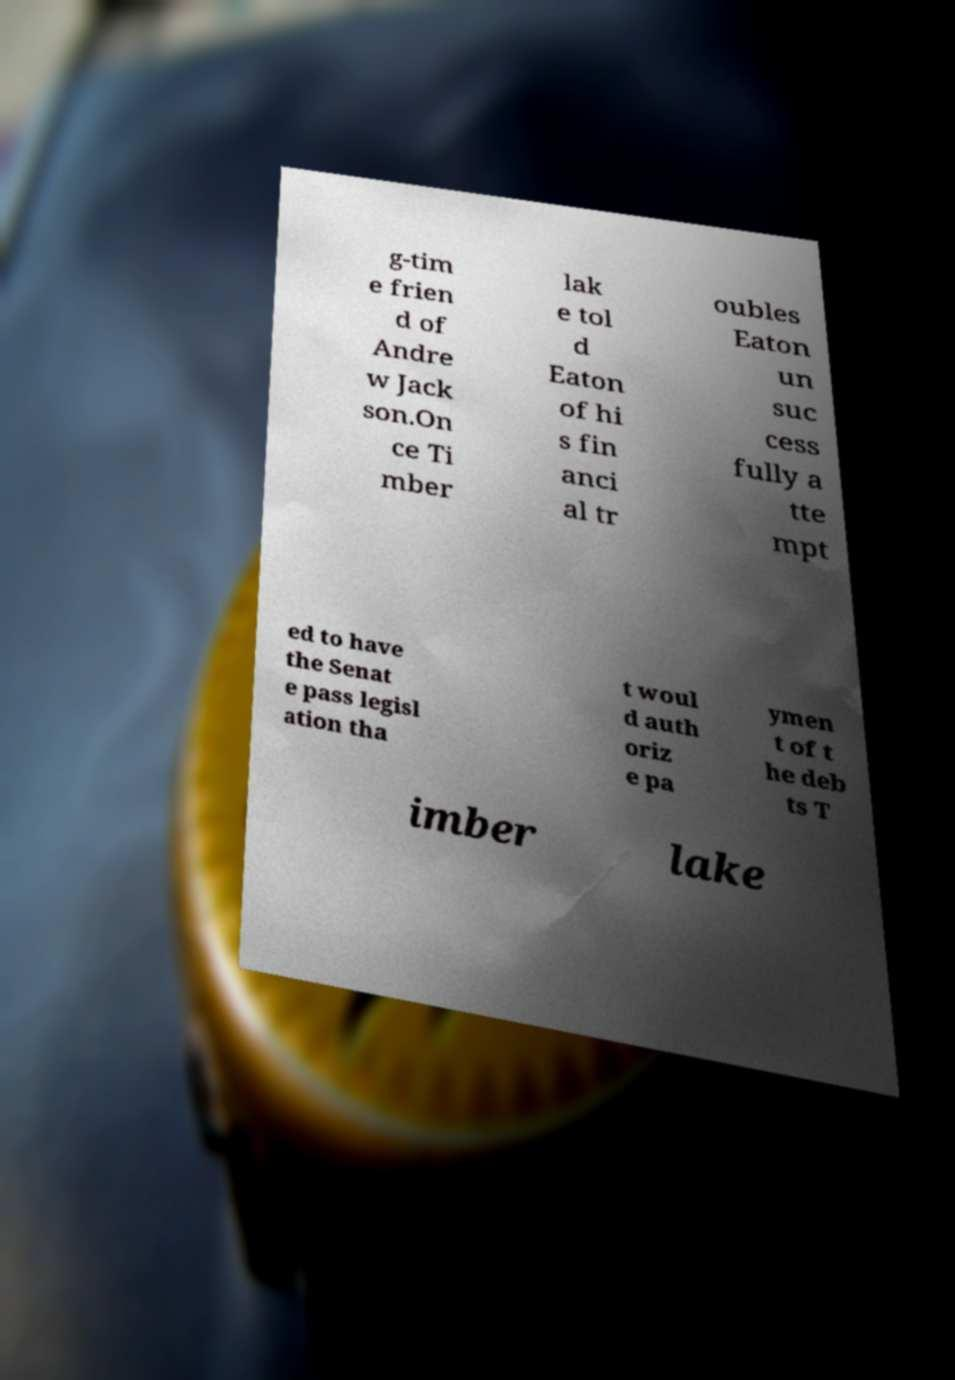Can you read and provide the text displayed in the image?This photo seems to have some interesting text. Can you extract and type it out for me? g-tim e frien d of Andre w Jack son.On ce Ti mber lak e tol d Eaton of hi s fin anci al tr oubles Eaton un suc cess fully a tte mpt ed to have the Senat e pass legisl ation tha t woul d auth oriz e pa ymen t of t he deb ts T imber lake 